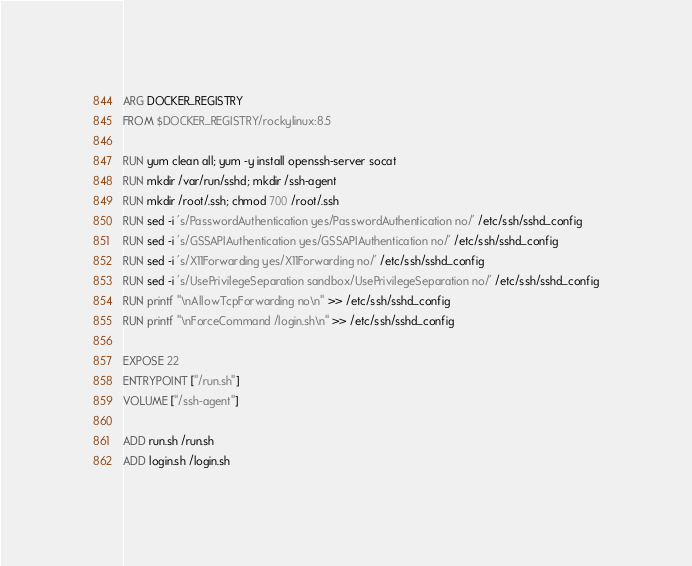<code> <loc_0><loc_0><loc_500><loc_500><_Dockerfile_>ARG DOCKER_REGISTRY
FROM $DOCKER_REGISTRY/rockylinux:8.5

RUN yum clean all; yum -y install openssh-server socat
RUN mkdir /var/run/sshd; mkdir /ssh-agent
RUN mkdir /root/.ssh; chmod 700 /root/.ssh
RUN sed -i 's/PasswordAuthentication yes/PasswordAuthentication no/' /etc/ssh/sshd_config
RUN sed -i 's/GSSAPIAuthentication yes/GSSAPIAuthentication no/' /etc/ssh/sshd_config
RUN sed -i 's/X11Forwarding yes/X11Forwarding no/' /etc/ssh/sshd_config
RUN sed -i 's/UsePrivilegeSeparation sandbox/UsePrivilegeSeparation no/' /etc/ssh/sshd_config
RUN printf "\nAllowTcpForwarding no\n" >> /etc/ssh/sshd_config
RUN printf "\nForceCommand /login.sh\n" >> /etc/ssh/sshd_config

EXPOSE 22
ENTRYPOINT ["/run.sh"]
VOLUME ["/ssh-agent"]

ADD run.sh /run.sh
ADD login.sh /login.sh

</code> 